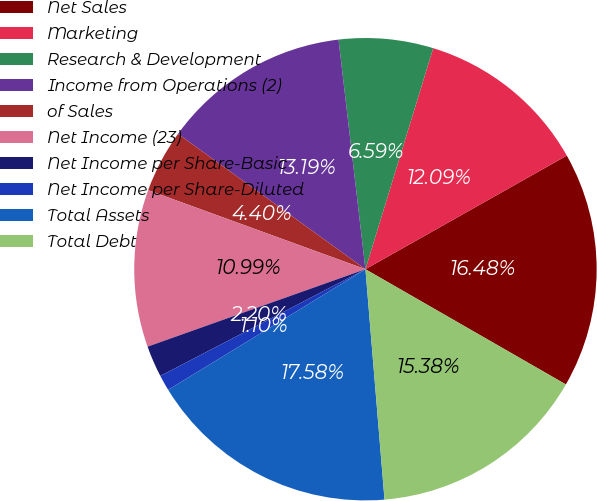Convert chart to OTSL. <chart><loc_0><loc_0><loc_500><loc_500><pie_chart><fcel>Net Sales<fcel>Marketing<fcel>Research & Development<fcel>Income from Operations (2)<fcel>of Sales<fcel>Net Income (23)<fcel>Net Income per Share-Basic<fcel>Net Income per Share-Diluted<fcel>Total Assets<fcel>Total Debt<nl><fcel>16.48%<fcel>12.09%<fcel>6.59%<fcel>13.19%<fcel>4.4%<fcel>10.99%<fcel>2.2%<fcel>1.1%<fcel>17.58%<fcel>15.38%<nl></chart> 